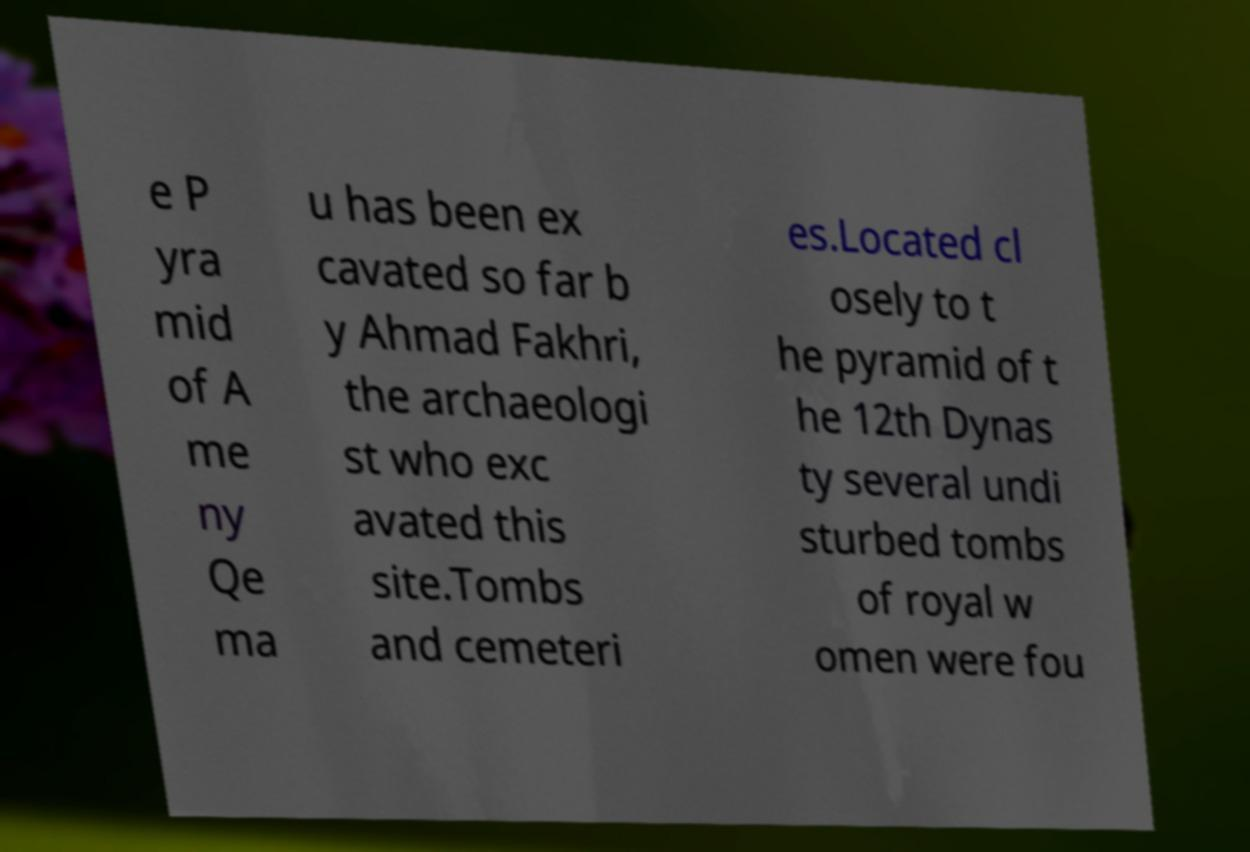There's text embedded in this image that I need extracted. Can you transcribe it verbatim? e P yra mid of A me ny Qe ma u has been ex cavated so far b y Ahmad Fakhri, the archaeologi st who exc avated this site.Tombs and cemeteri es.Located cl osely to t he pyramid of t he 12th Dynas ty several undi sturbed tombs of royal w omen were fou 